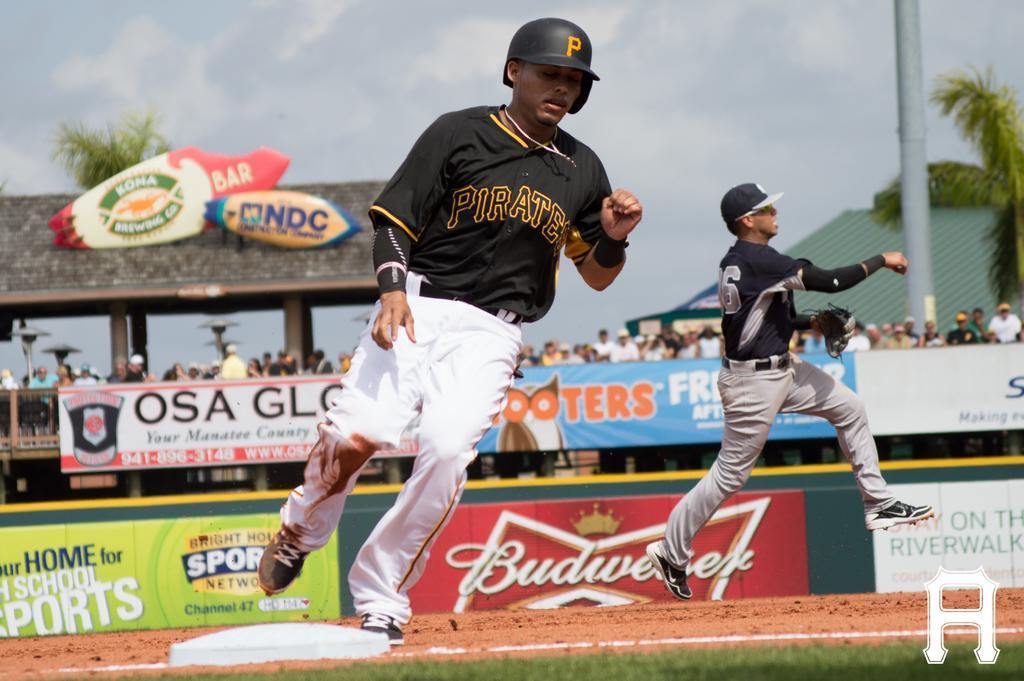How would you summarize this image in a sentence or two? In this image, I can see two persons running. In the background, there are hoardings, groups of people, boards, sheds, trees, a pole and the sky. In the bottom right corner of the image, I can see a watermark. At the bottom of the image, there is grass and an object on the ground. 